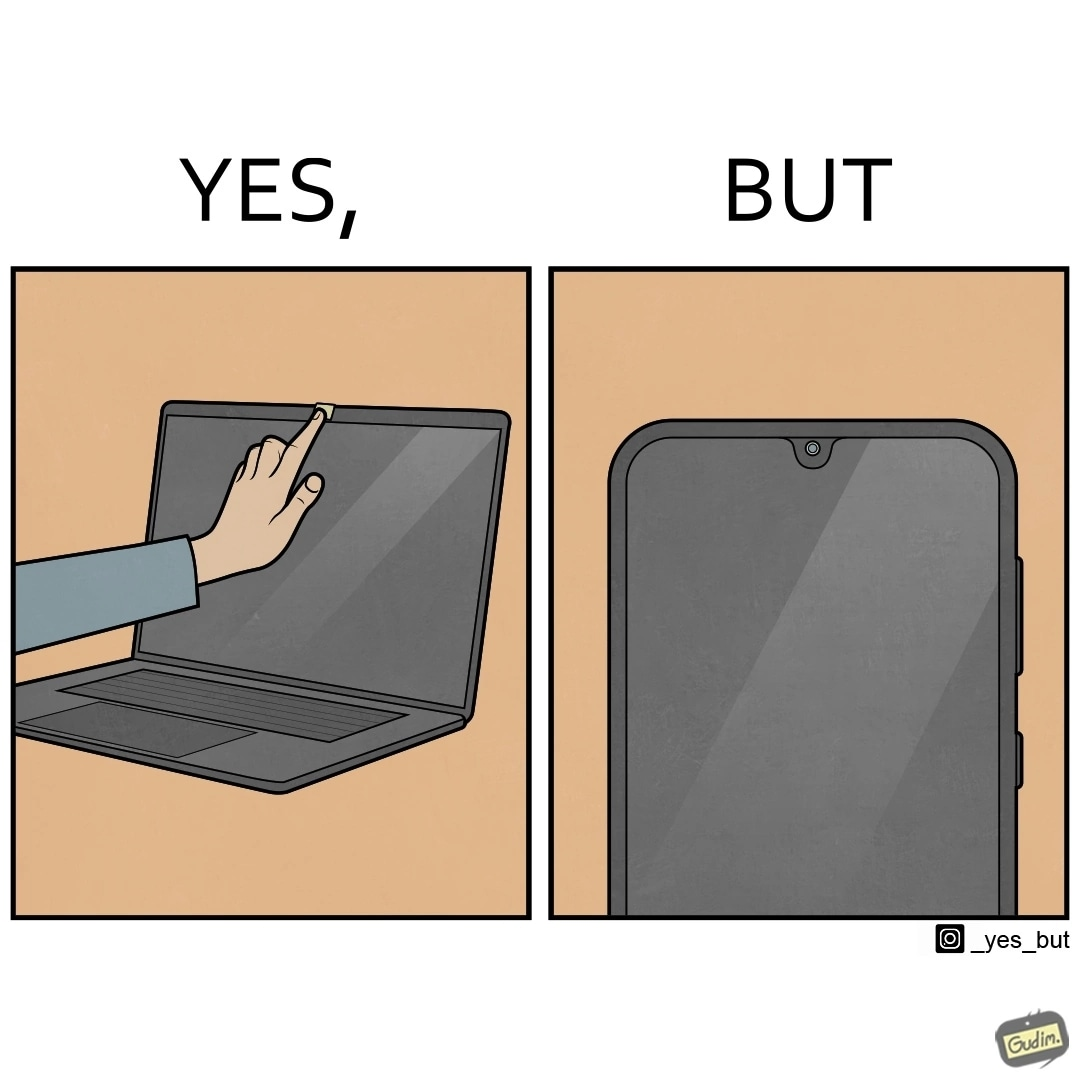What makes this image funny or satirical? The image is ironic, because the person is seen as applying tape over laptop's camera over some privacy concerns but on the other hand he/she carries the phone without covering its camera 